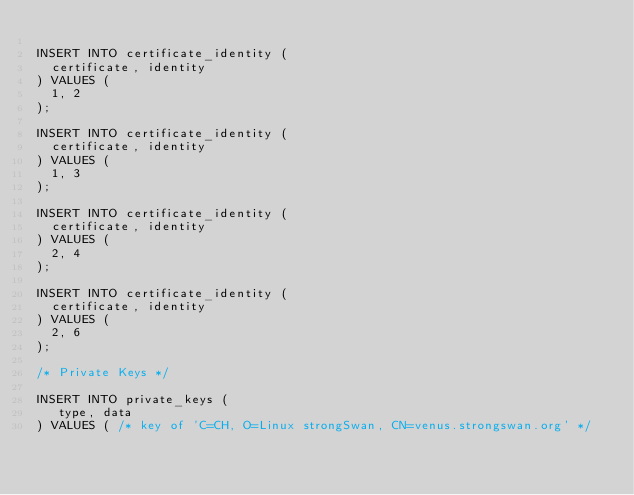Convert code to text. <code><loc_0><loc_0><loc_500><loc_500><_SQL_>
INSERT INTO certificate_identity (
  certificate, identity
) VALUES (
  1, 2
);

INSERT INTO certificate_identity (
  certificate, identity
) VALUES (
  1, 3
);

INSERT INTO certificate_identity (
  certificate, identity
) VALUES (
  2, 4
);

INSERT INTO certificate_identity (
  certificate, identity
) VALUES (
  2, 6
);

/* Private Keys */

INSERT INTO private_keys (
   type, data
) VALUES ( /* key of 'C=CH, O=Linux strongSwan, CN=venus.strongswan.org' */</code> 